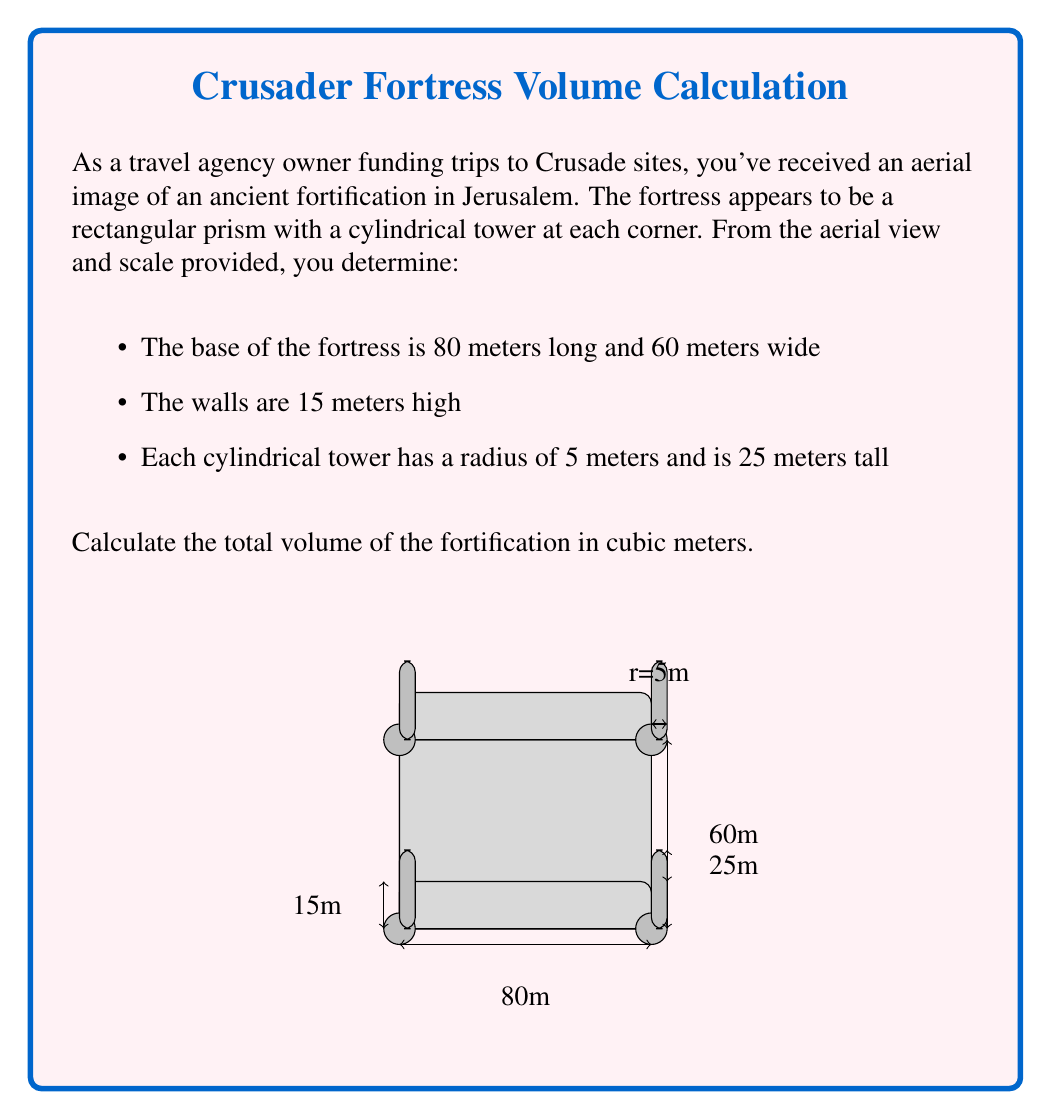Show me your answer to this math problem. Let's break this problem down into steps:

1) First, calculate the volume of the main rectangular fortress:
   $$V_{fortress} = length \times width \times height$$
   $$V_{fortress} = 80 \times 60 \times 15 = 72,000 \text{ m}^3$$

2) Next, calculate the volume of one cylindrical tower:
   $$V_{tower} = \pi r^2 h$$
   $$V_{tower} = \pi \times 5^2 \times 25 = 1,963.5 \text{ m}^3$$

3) There are four identical towers, so multiply the volume of one tower by 4:
   $$V_{all\_towers} = 4 \times 1,963.5 = 7,854 \text{ m}^3$$

4) However, part of each tower overlaps with the main fortress. We need to subtract this overlapping volume:
   $$V_{overlap} = \pi r^2 h_{fortress}$$
   $$V_{overlap} = \pi \times 5^2 \times 15 = 1,178.1 \text{ m}^3$$

5) Total overlap volume for all four towers:
   $$V_{total\_overlap} = 4 \times 1,178.1 = 4,712.4 \text{ m}^3$$

6) Now, calculate the total volume by adding the fortress volume and the tower volumes, then subtracting the overlap:
   $$V_{total} = V_{fortress} + V_{all\_towers} - V_{total\_overlap}$$
   $$V_{total} = 72,000 + 7,854 - 4,712.4 = 75,141.6 \text{ m}^3$$

7) Rounding to the nearest whole number:
   $$V_{total} \approx 75,142 \text{ m}^3$$
Answer: 75,142 m³ 